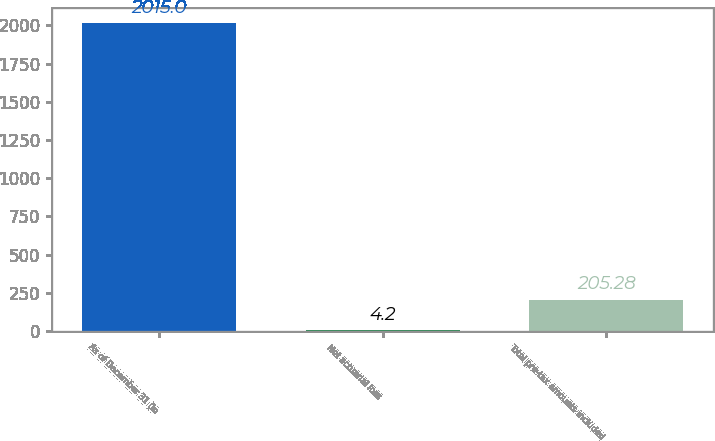Convert chart. <chart><loc_0><loc_0><loc_500><loc_500><bar_chart><fcel>As of December 31 (in<fcel>Net actuarial loss<fcel>Total pre-tax amounts included<nl><fcel>2015<fcel>4.2<fcel>205.28<nl></chart> 